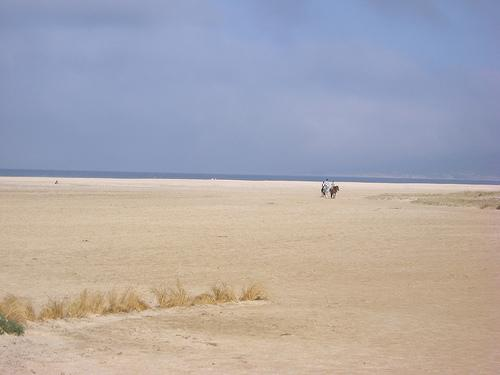Briefly mention the key elements and overall feel of the image. Two people walking on a vast sandy beach with ocean in the background, white clouds, clear blue sky, grass and plants growing, and horses ridden by people nearby. Acknowledge the possible emotions someone might feel while witnessing this scene. Watching the people strolling and horse riding along the beach, with the calming ocean waves and clear blue sky overhead, one might feel a sense of serenity and happiness. Detail the scene by mentioning the weather, time of day, and activities taking place. On a sunny day with clear blue skies, a couple casually strolls along the sandy beach, while other people ride horses and enjoy the ocean view in the background. Describe the image by mentioning its sizes, colors, and placement. Centered in the image, two people walk on a vast beach with a 153x153 size, while varying shades of blue compose a 492x492 ocean background, 449x449 clear sky, and punctuated by 25x25 horse riding figures. What impression does the image give you overall? A relaxing and peaceful scene at a large beach with people enjoying their time, surrounded by natural beauty and a clear blue sky. List the dominant aspects visible in the image, from foreground to background. Foreground: sandy beach, grass and plants; middle: two people walking, horse riding; background: ocean, white clouds, clear blue sky, distant mountains. Imagine a postcard of this image and create a message to a friend by describing the scene. Hey there! Enjoying a perfect day at the beach—clear blue skies, warm sand underfoot, people walking with breathtaking ocean views, and surprisingly, some horse riding too! Wish you were here! Narrate the scene as if you were there. As I walk along the sandy beach, I see a couple walking towards the water's edge, people riding horses nearby, and the vast ocean in the distance under a clear blue sky. Illustrate the image as a painting, including key elements and description of the color palette. In this tranquil beach painting, two people walk on golden sand, while vibrant green grass and plants frame the foreground. Shades of azure compose the ocean and sky, and lively horse riding adds color to the scene. Mention the various activities people can enjoy in this picturesque beach scene. Visitors can leisurely walk, relax on the sand, ride horses, admire the natural beauty of grass and plants, and take in the mesmerizing ocean and sky views. 